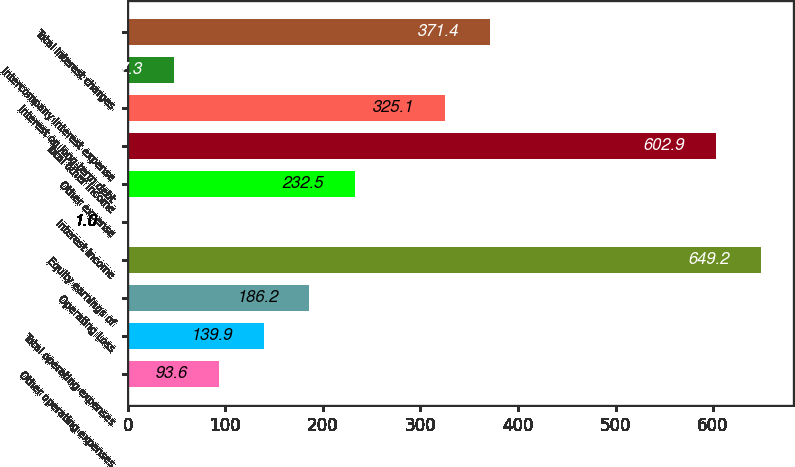Convert chart. <chart><loc_0><loc_0><loc_500><loc_500><bar_chart><fcel>Other operating expenses<fcel>Total operating expenses<fcel>Operating Loss<fcel>Equity earnings of<fcel>Interest income<fcel>Other expense<fcel>Total other income<fcel>Interest on long-term debt<fcel>Intercompany interest expense<fcel>Total interest charges<nl><fcel>93.6<fcel>139.9<fcel>186.2<fcel>649.2<fcel>1<fcel>232.5<fcel>602.9<fcel>325.1<fcel>47.3<fcel>371.4<nl></chart> 